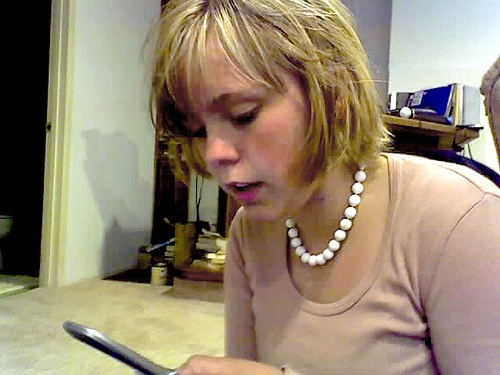Describe the objects in this image and their specific colors. I can see people in black, gray, darkgray, and tan tones, cell phone in black, darkgray, and gray tones, book in black, olive, gray, and khaki tones, book in black, gray, and olive tones, and book in black, white, beige, darkgray, and lightblue tones in this image. 